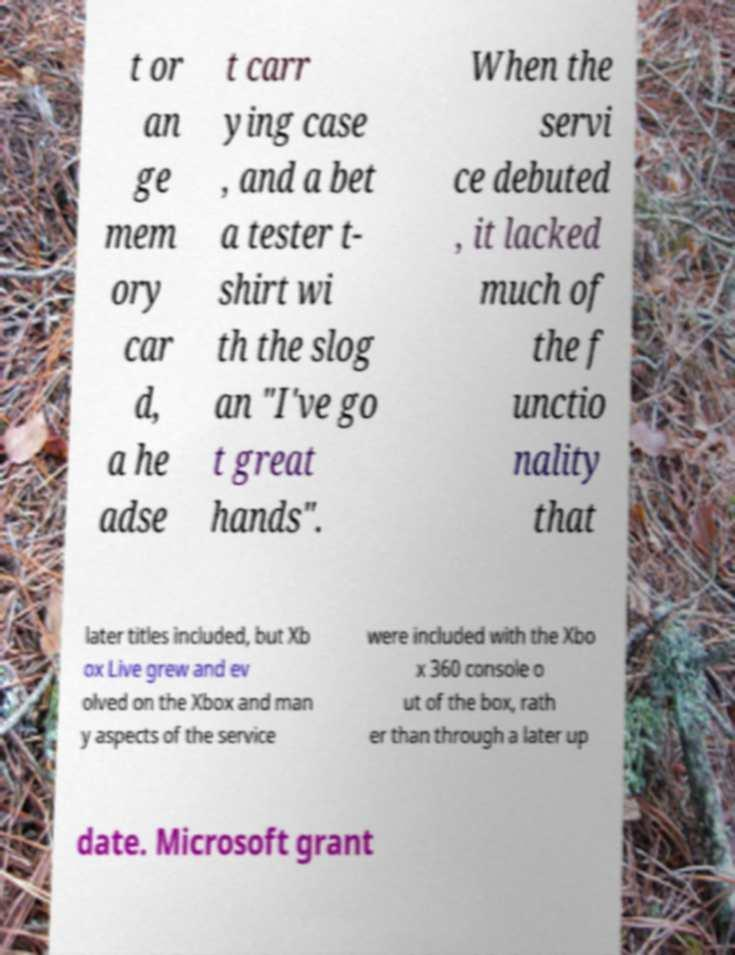Please identify and transcribe the text found in this image. t or an ge mem ory car d, a he adse t carr ying case , and a bet a tester t- shirt wi th the slog an "I've go t great hands". When the servi ce debuted , it lacked much of the f unctio nality that later titles included, but Xb ox Live grew and ev olved on the Xbox and man y aspects of the service were included with the Xbo x 360 console o ut of the box, rath er than through a later up date. Microsoft grant 